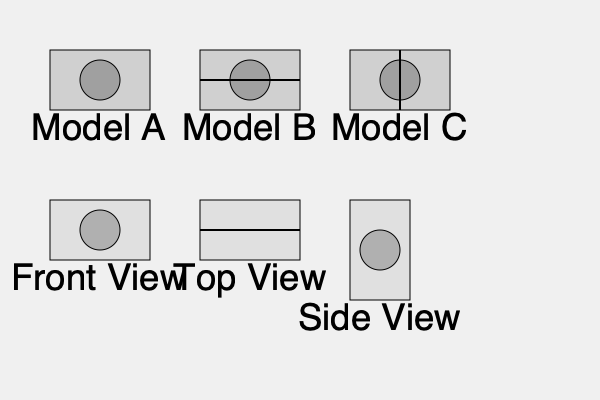As a space research enthusiast, you're analyzing different 3D models of a proposed International Lunar Research Station. Given the front, top, and side view projections shown in the image, which of the 3D models (A, B, or C) correctly represents the space station? To determine the correct 3D model, we need to analyze each projection and compare it with the given models:

1. Front View:
   - Shows a rectangle with a circular feature in the center.
   - All three models (A, B, and C) match this view.

2. Top View:
   - Displays a rectangle with a horizontal line across the middle.
   - Only Model B has this horizontal line, which could represent a dividing feature or structural element.

3. Side View:
   - Presents a rectangle with a circular feature in the center.
   - All three models (A, B, and C) match this view.

4. Comparing the models:
   - Model A lacks the horizontal line seen in the top view.
   - Model B matches all three projections, including the crucial horizontal line in the top view.
   - Model C has a vertical line instead of the required horizontal line.

5. Conclusion:
   Model B is the only one that correctly represents all three projections of the space station.

This analysis demonstrates the importance of considering multiple perspectives in space station design, a crucial aspect of space research that combines engineering precision with the need for efficient use of space – themes that resonate with both space enthusiasts and those advocating for equal representation in STEM fields.
Answer: Model B 